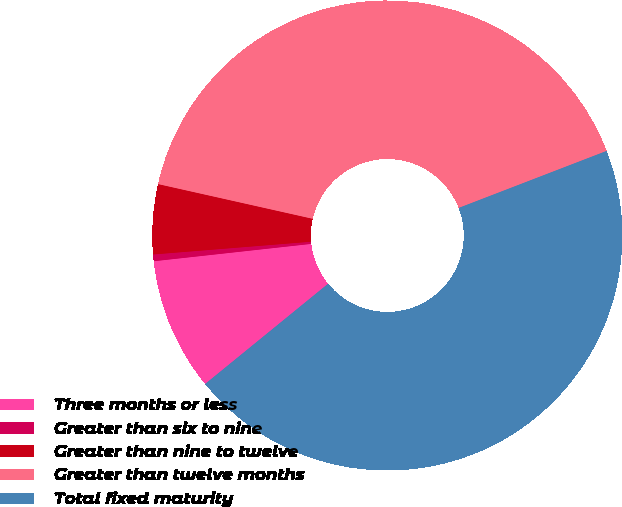<chart> <loc_0><loc_0><loc_500><loc_500><pie_chart><fcel>Three months or less<fcel>Greater than six to nine<fcel>Greater than nine to twelve<fcel>Greater than twelve months<fcel>Total fixed maturity<nl><fcel>9.14%<fcel>0.46%<fcel>4.8%<fcel>40.63%<fcel>44.97%<nl></chart> 